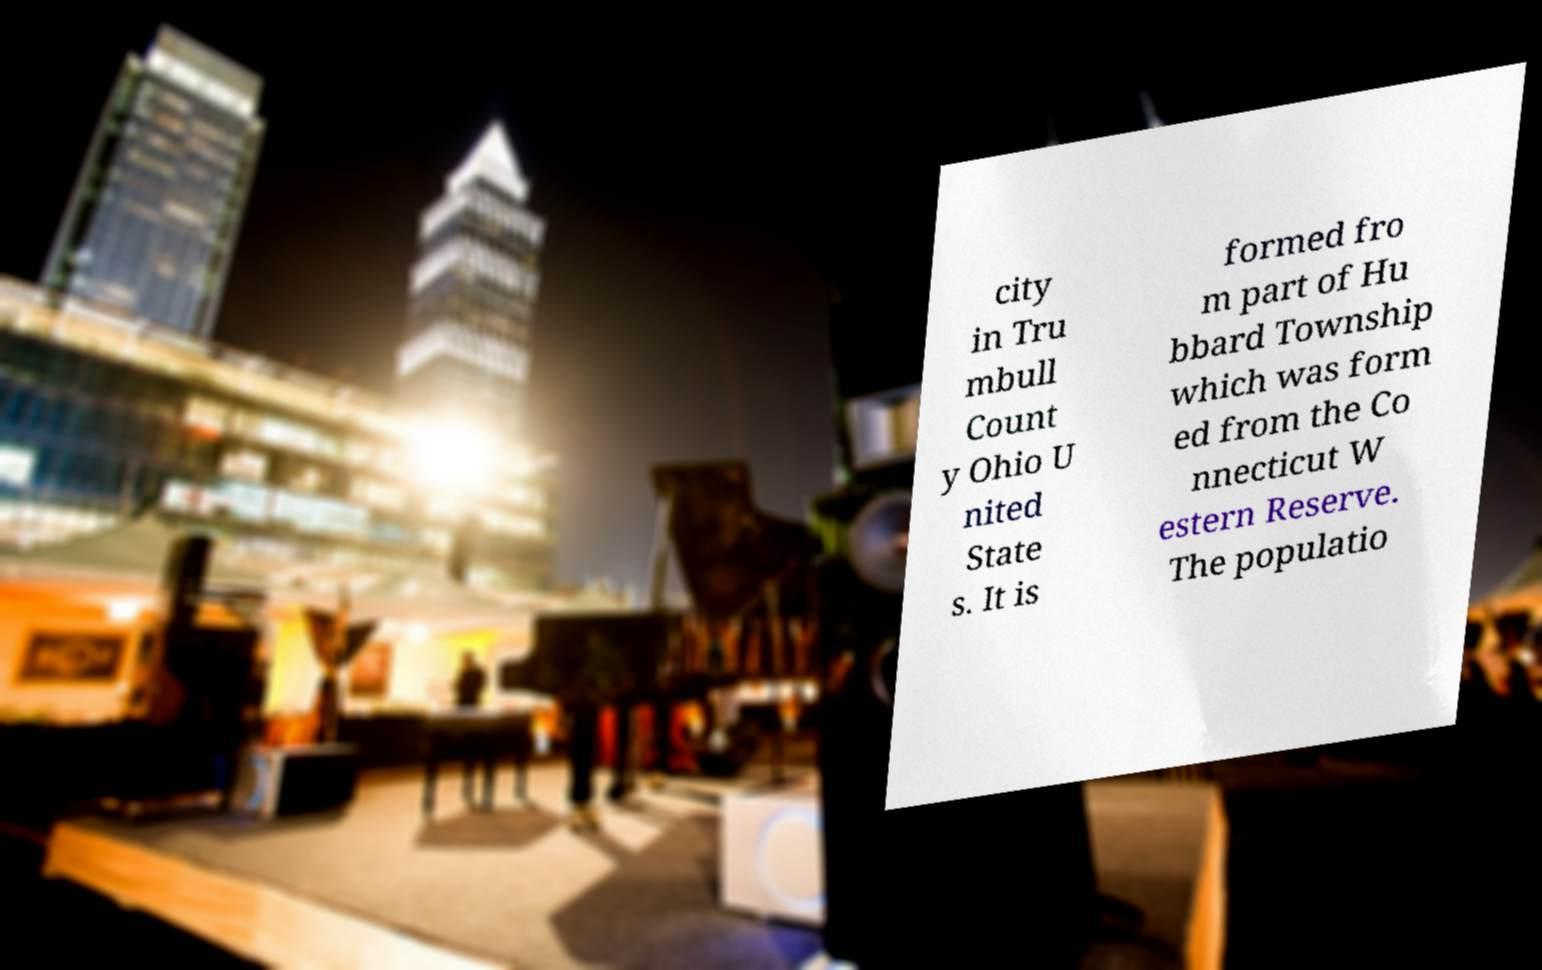I need the written content from this picture converted into text. Can you do that? city in Tru mbull Count y Ohio U nited State s. It is formed fro m part of Hu bbard Township which was form ed from the Co nnecticut W estern Reserve. The populatio 